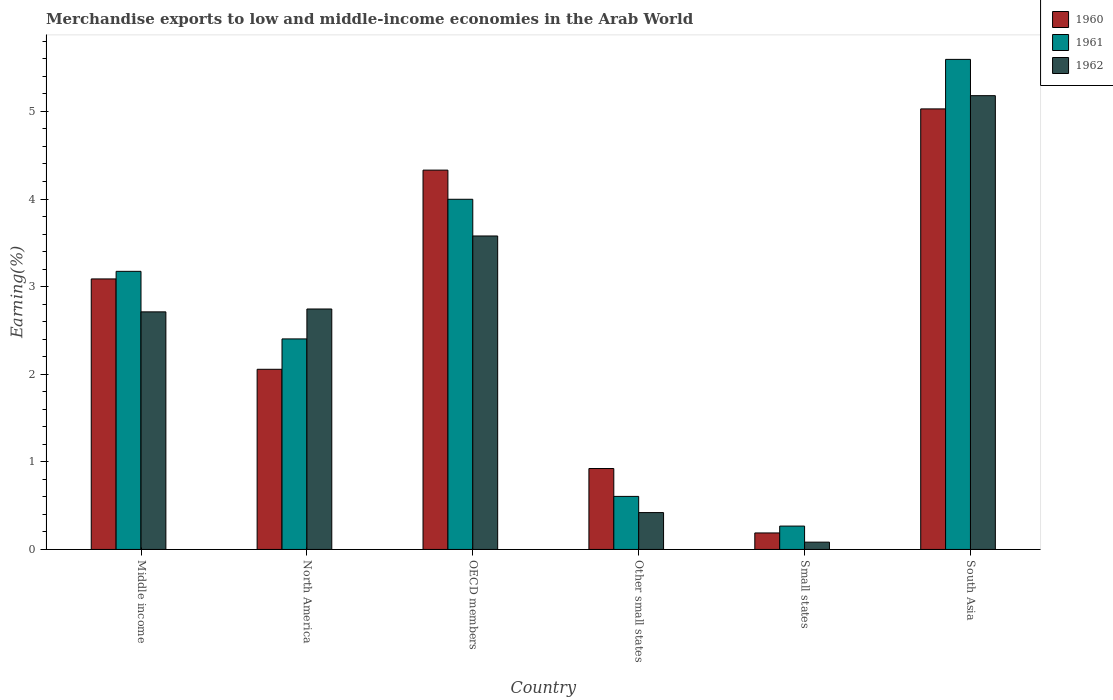How many different coloured bars are there?
Offer a terse response. 3. Are the number of bars per tick equal to the number of legend labels?
Offer a very short reply. Yes. Are the number of bars on each tick of the X-axis equal?
Give a very brief answer. Yes. What is the label of the 5th group of bars from the left?
Your answer should be very brief. Small states. In how many cases, is the number of bars for a given country not equal to the number of legend labels?
Your answer should be very brief. 0. What is the percentage of amount earned from merchandise exports in 1962 in Middle income?
Your answer should be compact. 2.71. Across all countries, what is the maximum percentage of amount earned from merchandise exports in 1962?
Your response must be concise. 5.18. Across all countries, what is the minimum percentage of amount earned from merchandise exports in 1961?
Ensure brevity in your answer.  0.27. In which country was the percentage of amount earned from merchandise exports in 1962 minimum?
Give a very brief answer. Small states. What is the total percentage of amount earned from merchandise exports in 1962 in the graph?
Your response must be concise. 14.72. What is the difference between the percentage of amount earned from merchandise exports in 1962 in North America and that in Small states?
Your response must be concise. 2.66. What is the difference between the percentage of amount earned from merchandise exports in 1962 in OECD members and the percentage of amount earned from merchandise exports in 1960 in South Asia?
Ensure brevity in your answer.  -1.45. What is the average percentage of amount earned from merchandise exports in 1961 per country?
Offer a terse response. 2.67. What is the difference between the percentage of amount earned from merchandise exports of/in 1962 and percentage of amount earned from merchandise exports of/in 1961 in South Asia?
Provide a short and direct response. -0.41. What is the ratio of the percentage of amount earned from merchandise exports in 1962 in Other small states to that in Small states?
Give a very brief answer. 5.05. Is the difference between the percentage of amount earned from merchandise exports in 1962 in Middle income and Small states greater than the difference between the percentage of amount earned from merchandise exports in 1961 in Middle income and Small states?
Make the answer very short. No. What is the difference between the highest and the second highest percentage of amount earned from merchandise exports in 1962?
Offer a terse response. -0.83. What is the difference between the highest and the lowest percentage of amount earned from merchandise exports in 1962?
Make the answer very short. 5.1. In how many countries, is the percentage of amount earned from merchandise exports in 1962 greater than the average percentage of amount earned from merchandise exports in 1962 taken over all countries?
Give a very brief answer. 4. Is the sum of the percentage of amount earned from merchandise exports in 1960 in Middle income and Small states greater than the maximum percentage of amount earned from merchandise exports in 1962 across all countries?
Provide a succinct answer. No. What does the 3rd bar from the left in Other small states represents?
Your response must be concise. 1962. What does the 1st bar from the right in South Asia represents?
Make the answer very short. 1962. How many bars are there?
Give a very brief answer. 18. Are all the bars in the graph horizontal?
Offer a terse response. No. How many countries are there in the graph?
Ensure brevity in your answer.  6. What is the difference between two consecutive major ticks on the Y-axis?
Your response must be concise. 1. Are the values on the major ticks of Y-axis written in scientific E-notation?
Keep it short and to the point. No. Does the graph contain any zero values?
Provide a short and direct response. No. Does the graph contain grids?
Ensure brevity in your answer.  No. Where does the legend appear in the graph?
Your answer should be compact. Top right. How many legend labels are there?
Give a very brief answer. 3. What is the title of the graph?
Give a very brief answer. Merchandise exports to low and middle-income economies in the Arab World. What is the label or title of the X-axis?
Your answer should be compact. Country. What is the label or title of the Y-axis?
Give a very brief answer. Earning(%). What is the Earning(%) in 1960 in Middle income?
Provide a short and direct response. 3.09. What is the Earning(%) of 1961 in Middle income?
Provide a succinct answer. 3.17. What is the Earning(%) of 1962 in Middle income?
Give a very brief answer. 2.71. What is the Earning(%) of 1960 in North America?
Provide a short and direct response. 2.06. What is the Earning(%) in 1961 in North America?
Your response must be concise. 2.4. What is the Earning(%) of 1962 in North America?
Give a very brief answer. 2.74. What is the Earning(%) of 1960 in OECD members?
Offer a very short reply. 4.33. What is the Earning(%) in 1961 in OECD members?
Provide a succinct answer. 4. What is the Earning(%) of 1962 in OECD members?
Provide a succinct answer. 3.58. What is the Earning(%) of 1960 in Other small states?
Your answer should be compact. 0.92. What is the Earning(%) in 1961 in Other small states?
Give a very brief answer. 0.61. What is the Earning(%) in 1962 in Other small states?
Keep it short and to the point. 0.42. What is the Earning(%) in 1960 in Small states?
Your response must be concise. 0.19. What is the Earning(%) in 1961 in Small states?
Your answer should be very brief. 0.27. What is the Earning(%) in 1962 in Small states?
Keep it short and to the point. 0.08. What is the Earning(%) in 1960 in South Asia?
Offer a very short reply. 5.03. What is the Earning(%) of 1961 in South Asia?
Your answer should be very brief. 5.59. What is the Earning(%) of 1962 in South Asia?
Make the answer very short. 5.18. Across all countries, what is the maximum Earning(%) of 1960?
Your answer should be very brief. 5.03. Across all countries, what is the maximum Earning(%) in 1961?
Provide a short and direct response. 5.59. Across all countries, what is the maximum Earning(%) of 1962?
Offer a terse response. 5.18. Across all countries, what is the minimum Earning(%) of 1960?
Give a very brief answer. 0.19. Across all countries, what is the minimum Earning(%) of 1961?
Give a very brief answer. 0.27. Across all countries, what is the minimum Earning(%) in 1962?
Offer a terse response. 0.08. What is the total Earning(%) of 1960 in the graph?
Give a very brief answer. 15.62. What is the total Earning(%) of 1961 in the graph?
Offer a very short reply. 16.04. What is the total Earning(%) of 1962 in the graph?
Make the answer very short. 14.72. What is the difference between the Earning(%) of 1960 in Middle income and that in North America?
Provide a short and direct response. 1.03. What is the difference between the Earning(%) of 1961 in Middle income and that in North America?
Provide a short and direct response. 0.77. What is the difference between the Earning(%) in 1962 in Middle income and that in North America?
Offer a very short reply. -0.03. What is the difference between the Earning(%) of 1960 in Middle income and that in OECD members?
Your response must be concise. -1.24. What is the difference between the Earning(%) of 1961 in Middle income and that in OECD members?
Make the answer very short. -0.82. What is the difference between the Earning(%) in 1962 in Middle income and that in OECD members?
Make the answer very short. -0.87. What is the difference between the Earning(%) of 1960 in Middle income and that in Other small states?
Offer a terse response. 2.16. What is the difference between the Earning(%) in 1961 in Middle income and that in Other small states?
Your answer should be compact. 2.57. What is the difference between the Earning(%) in 1962 in Middle income and that in Other small states?
Ensure brevity in your answer.  2.29. What is the difference between the Earning(%) in 1960 in Middle income and that in Small states?
Provide a succinct answer. 2.9. What is the difference between the Earning(%) of 1961 in Middle income and that in Small states?
Offer a very short reply. 2.91. What is the difference between the Earning(%) of 1962 in Middle income and that in Small states?
Provide a succinct answer. 2.63. What is the difference between the Earning(%) of 1960 in Middle income and that in South Asia?
Ensure brevity in your answer.  -1.94. What is the difference between the Earning(%) in 1961 in Middle income and that in South Asia?
Make the answer very short. -2.42. What is the difference between the Earning(%) of 1962 in Middle income and that in South Asia?
Keep it short and to the point. -2.47. What is the difference between the Earning(%) in 1960 in North America and that in OECD members?
Give a very brief answer. -2.27. What is the difference between the Earning(%) of 1961 in North America and that in OECD members?
Provide a succinct answer. -1.59. What is the difference between the Earning(%) in 1962 in North America and that in OECD members?
Ensure brevity in your answer.  -0.83. What is the difference between the Earning(%) of 1960 in North America and that in Other small states?
Make the answer very short. 1.13. What is the difference between the Earning(%) in 1961 in North America and that in Other small states?
Provide a short and direct response. 1.8. What is the difference between the Earning(%) in 1962 in North America and that in Other small states?
Ensure brevity in your answer.  2.32. What is the difference between the Earning(%) of 1960 in North America and that in Small states?
Give a very brief answer. 1.87. What is the difference between the Earning(%) in 1961 in North America and that in Small states?
Give a very brief answer. 2.14. What is the difference between the Earning(%) of 1962 in North America and that in Small states?
Offer a very short reply. 2.66. What is the difference between the Earning(%) of 1960 in North America and that in South Asia?
Provide a succinct answer. -2.97. What is the difference between the Earning(%) in 1961 in North America and that in South Asia?
Give a very brief answer. -3.19. What is the difference between the Earning(%) in 1962 in North America and that in South Asia?
Your response must be concise. -2.44. What is the difference between the Earning(%) of 1960 in OECD members and that in Other small states?
Provide a succinct answer. 3.41. What is the difference between the Earning(%) of 1961 in OECD members and that in Other small states?
Make the answer very short. 3.39. What is the difference between the Earning(%) in 1962 in OECD members and that in Other small states?
Your answer should be very brief. 3.16. What is the difference between the Earning(%) in 1960 in OECD members and that in Small states?
Make the answer very short. 4.14. What is the difference between the Earning(%) of 1961 in OECD members and that in Small states?
Your response must be concise. 3.73. What is the difference between the Earning(%) of 1962 in OECD members and that in Small states?
Your response must be concise. 3.49. What is the difference between the Earning(%) of 1960 in OECD members and that in South Asia?
Your answer should be very brief. -0.7. What is the difference between the Earning(%) of 1961 in OECD members and that in South Asia?
Provide a short and direct response. -1.6. What is the difference between the Earning(%) in 1962 in OECD members and that in South Asia?
Give a very brief answer. -1.6. What is the difference between the Earning(%) in 1960 in Other small states and that in Small states?
Offer a terse response. 0.74. What is the difference between the Earning(%) of 1961 in Other small states and that in Small states?
Your response must be concise. 0.34. What is the difference between the Earning(%) in 1962 in Other small states and that in Small states?
Offer a terse response. 0.34. What is the difference between the Earning(%) in 1960 in Other small states and that in South Asia?
Your answer should be compact. -4.1. What is the difference between the Earning(%) in 1961 in Other small states and that in South Asia?
Keep it short and to the point. -4.99. What is the difference between the Earning(%) of 1962 in Other small states and that in South Asia?
Keep it short and to the point. -4.76. What is the difference between the Earning(%) of 1960 in Small states and that in South Asia?
Make the answer very short. -4.84. What is the difference between the Earning(%) of 1961 in Small states and that in South Asia?
Provide a succinct answer. -5.33. What is the difference between the Earning(%) in 1962 in Small states and that in South Asia?
Keep it short and to the point. -5.1. What is the difference between the Earning(%) of 1960 in Middle income and the Earning(%) of 1961 in North America?
Your response must be concise. 0.68. What is the difference between the Earning(%) of 1960 in Middle income and the Earning(%) of 1962 in North America?
Offer a terse response. 0.34. What is the difference between the Earning(%) of 1961 in Middle income and the Earning(%) of 1962 in North America?
Provide a succinct answer. 0.43. What is the difference between the Earning(%) in 1960 in Middle income and the Earning(%) in 1961 in OECD members?
Provide a short and direct response. -0.91. What is the difference between the Earning(%) of 1960 in Middle income and the Earning(%) of 1962 in OECD members?
Provide a succinct answer. -0.49. What is the difference between the Earning(%) of 1961 in Middle income and the Earning(%) of 1962 in OECD members?
Keep it short and to the point. -0.4. What is the difference between the Earning(%) of 1960 in Middle income and the Earning(%) of 1961 in Other small states?
Keep it short and to the point. 2.48. What is the difference between the Earning(%) of 1960 in Middle income and the Earning(%) of 1962 in Other small states?
Offer a terse response. 2.67. What is the difference between the Earning(%) in 1961 in Middle income and the Earning(%) in 1962 in Other small states?
Offer a very short reply. 2.75. What is the difference between the Earning(%) in 1960 in Middle income and the Earning(%) in 1961 in Small states?
Your answer should be compact. 2.82. What is the difference between the Earning(%) in 1960 in Middle income and the Earning(%) in 1962 in Small states?
Provide a short and direct response. 3. What is the difference between the Earning(%) of 1961 in Middle income and the Earning(%) of 1962 in Small states?
Your response must be concise. 3.09. What is the difference between the Earning(%) of 1960 in Middle income and the Earning(%) of 1961 in South Asia?
Offer a terse response. -2.51. What is the difference between the Earning(%) in 1960 in Middle income and the Earning(%) in 1962 in South Asia?
Ensure brevity in your answer.  -2.09. What is the difference between the Earning(%) of 1961 in Middle income and the Earning(%) of 1962 in South Asia?
Offer a terse response. -2.01. What is the difference between the Earning(%) of 1960 in North America and the Earning(%) of 1961 in OECD members?
Provide a succinct answer. -1.94. What is the difference between the Earning(%) in 1960 in North America and the Earning(%) in 1962 in OECD members?
Provide a succinct answer. -1.52. What is the difference between the Earning(%) in 1961 in North America and the Earning(%) in 1962 in OECD members?
Your response must be concise. -1.17. What is the difference between the Earning(%) of 1960 in North America and the Earning(%) of 1961 in Other small states?
Your answer should be very brief. 1.45. What is the difference between the Earning(%) in 1960 in North America and the Earning(%) in 1962 in Other small states?
Give a very brief answer. 1.64. What is the difference between the Earning(%) in 1961 in North America and the Earning(%) in 1962 in Other small states?
Provide a succinct answer. 1.98. What is the difference between the Earning(%) of 1960 in North America and the Earning(%) of 1961 in Small states?
Make the answer very short. 1.79. What is the difference between the Earning(%) in 1960 in North America and the Earning(%) in 1962 in Small states?
Provide a succinct answer. 1.97. What is the difference between the Earning(%) in 1961 in North America and the Earning(%) in 1962 in Small states?
Provide a succinct answer. 2.32. What is the difference between the Earning(%) in 1960 in North America and the Earning(%) in 1961 in South Asia?
Your response must be concise. -3.54. What is the difference between the Earning(%) in 1960 in North America and the Earning(%) in 1962 in South Asia?
Provide a succinct answer. -3.12. What is the difference between the Earning(%) of 1961 in North America and the Earning(%) of 1962 in South Asia?
Provide a short and direct response. -2.78. What is the difference between the Earning(%) of 1960 in OECD members and the Earning(%) of 1961 in Other small states?
Your response must be concise. 3.72. What is the difference between the Earning(%) in 1960 in OECD members and the Earning(%) in 1962 in Other small states?
Make the answer very short. 3.91. What is the difference between the Earning(%) of 1961 in OECD members and the Earning(%) of 1962 in Other small states?
Keep it short and to the point. 3.58. What is the difference between the Earning(%) of 1960 in OECD members and the Earning(%) of 1961 in Small states?
Your response must be concise. 4.06. What is the difference between the Earning(%) in 1960 in OECD members and the Earning(%) in 1962 in Small states?
Provide a succinct answer. 4.25. What is the difference between the Earning(%) in 1961 in OECD members and the Earning(%) in 1962 in Small states?
Give a very brief answer. 3.91. What is the difference between the Earning(%) of 1960 in OECD members and the Earning(%) of 1961 in South Asia?
Offer a very short reply. -1.26. What is the difference between the Earning(%) of 1960 in OECD members and the Earning(%) of 1962 in South Asia?
Your answer should be compact. -0.85. What is the difference between the Earning(%) in 1961 in OECD members and the Earning(%) in 1962 in South Asia?
Offer a terse response. -1.18. What is the difference between the Earning(%) of 1960 in Other small states and the Earning(%) of 1961 in Small states?
Keep it short and to the point. 0.66. What is the difference between the Earning(%) of 1960 in Other small states and the Earning(%) of 1962 in Small states?
Offer a terse response. 0.84. What is the difference between the Earning(%) of 1961 in Other small states and the Earning(%) of 1962 in Small states?
Keep it short and to the point. 0.52. What is the difference between the Earning(%) of 1960 in Other small states and the Earning(%) of 1961 in South Asia?
Your answer should be compact. -4.67. What is the difference between the Earning(%) of 1960 in Other small states and the Earning(%) of 1962 in South Asia?
Offer a very short reply. -4.26. What is the difference between the Earning(%) in 1961 in Other small states and the Earning(%) in 1962 in South Asia?
Give a very brief answer. -4.57. What is the difference between the Earning(%) in 1960 in Small states and the Earning(%) in 1961 in South Asia?
Your answer should be compact. -5.41. What is the difference between the Earning(%) of 1960 in Small states and the Earning(%) of 1962 in South Asia?
Ensure brevity in your answer.  -4.99. What is the difference between the Earning(%) of 1961 in Small states and the Earning(%) of 1962 in South Asia?
Your response must be concise. -4.91. What is the average Earning(%) in 1960 per country?
Provide a short and direct response. 2.6. What is the average Earning(%) of 1961 per country?
Offer a terse response. 2.67. What is the average Earning(%) of 1962 per country?
Ensure brevity in your answer.  2.45. What is the difference between the Earning(%) of 1960 and Earning(%) of 1961 in Middle income?
Make the answer very short. -0.09. What is the difference between the Earning(%) in 1960 and Earning(%) in 1962 in Middle income?
Offer a very short reply. 0.38. What is the difference between the Earning(%) in 1961 and Earning(%) in 1962 in Middle income?
Offer a terse response. 0.46. What is the difference between the Earning(%) of 1960 and Earning(%) of 1961 in North America?
Offer a terse response. -0.35. What is the difference between the Earning(%) of 1960 and Earning(%) of 1962 in North America?
Your answer should be compact. -0.69. What is the difference between the Earning(%) of 1961 and Earning(%) of 1962 in North America?
Offer a terse response. -0.34. What is the difference between the Earning(%) of 1960 and Earning(%) of 1961 in OECD members?
Offer a very short reply. 0.33. What is the difference between the Earning(%) in 1960 and Earning(%) in 1962 in OECD members?
Your answer should be very brief. 0.75. What is the difference between the Earning(%) in 1961 and Earning(%) in 1962 in OECD members?
Give a very brief answer. 0.42. What is the difference between the Earning(%) of 1960 and Earning(%) of 1961 in Other small states?
Give a very brief answer. 0.32. What is the difference between the Earning(%) in 1960 and Earning(%) in 1962 in Other small states?
Offer a very short reply. 0.5. What is the difference between the Earning(%) in 1961 and Earning(%) in 1962 in Other small states?
Your answer should be very brief. 0.18. What is the difference between the Earning(%) of 1960 and Earning(%) of 1961 in Small states?
Ensure brevity in your answer.  -0.08. What is the difference between the Earning(%) of 1960 and Earning(%) of 1962 in Small states?
Provide a succinct answer. 0.11. What is the difference between the Earning(%) of 1961 and Earning(%) of 1962 in Small states?
Provide a succinct answer. 0.18. What is the difference between the Earning(%) in 1960 and Earning(%) in 1961 in South Asia?
Give a very brief answer. -0.57. What is the difference between the Earning(%) in 1960 and Earning(%) in 1962 in South Asia?
Your answer should be very brief. -0.15. What is the difference between the Earning(%) of 1961 and Earning(%) of 1962 in South Asia?
Offer a terse response. 0.41. What is the ratio of the Earning(%) in 1960 in Middle income to that in North America?
Ensure brevity in your answer.  1.5. What is the ratio of the Earning(%) in 1961 in Middle income to that in North America?
Ensure brevity in your answer.  1.32. What is the ratio of the Earning(%) of 1960 in Middle income to that in OECD members?
Offer a terse response. 0.71. What is the ratio of the Earning(%) of 1961 in Middle income to that in OECD members?
Provide a succinct answer. 0.79. What is the ratio of the Earning(%) in 1962 in Middle income to that in OECD members?
Provide a short and direct response. 0.76. What is the ratio of the Earning(%) in 1960 in Middle income to that in Other small states?
Your answer should be very brief. 3.34. What is the ratio of the Earning(%) in 1961 in Middle income to that in Other small states?
Keep it short and to the point. 5.24. What is the ratio of the Earning(%) of 1962 in Middle income to that in Other small states?
Make the answer very short. 6.44. What is the ratio of the Earning(%) of 1960 in Middle income to that in Small states?
Your answer should be compact. 16.39. What is the ratio of the Earning(%) in 1961 in Middle income to that in Small states?
Make the answer very short. 11.9. What is the ratio of the Earning(%) in 1962 in Middle income to that in Small states?
Keep it short and to the point. 32.54. What is the ratio of the Earning(%) in 1960 in Middle income to that in South Asia?
Offer a very short reply. 0.61. What is the ratio of the Earning(%) in 1961 in Middle income to that in South Asia?
Your answer should be compact. 0.57. What is the ratio of the Earning(%) in 1962 in Middle income to that in South Asia?
Provide a short and direct response. 0.52. What is the ratio of the Earning(%) of 1960 in North America to that in OECD members?
Keep it short and to the point. 0.47. What is the ratio of the Earning(%) in 1961 in North America to that in OECD members?
Make the answer very short. 0.6. What is the ratio of the Earning(%) in 1962 in North America to that in OECD members?
Provide a short and direct response. 0.77. What is the ratio of the Earning(%) of 1960 in North America to that in Other small states?
Give a very brief answer. 2.23. What is the ratio of the Earning(%) in 1961 in North America to that in Other small states?
Keep it short and to the point. 3.97. What is the ratio of the Earning(%) of 1962 in North America to that in Other small states?
Offer a very short reply. 6.52. What is the ratio of the Earning(%) in 1960 in North America to that in Small states?
Provide a succinct answer. 10.91. What is the ratio of the Earning(%) of 1961 in North America to that in Small states?
Keep it short and to the point. 9.01. What is the ratio of the Earning(%) in 1962 in North America to that in Small states?
Your answer should be compact. 32.94. What is the ratio of the Earning(%) of 1960 in North America to that in South Asia?
Keep it short and to the point. 0.41. What is the ratio of the Earning(%) of 1961 in North America to that in South Asia?
Ensure brevity in your answer.  0.43. What is the ratio of the Earning(%) of 1962 in North America to that in South Asia?
Provide a short and direct response. 0.53. What is the ratio of the Earning(%) of 1960 in OECD members to that in Other small states?
Offer a terse response. 4.69. What is the ratio of the Earning(%) of 1961 in OECD members to that in Other small states?
Ensure brevity in your answer.  6.6. What is the ratio of the Earning(%) in 1962 in OECD members to that in Other small states?
Provide a succinct answer. 8.5. What is the ratio of the Earning(%) in 1960 in OECD members to that in Small states?
Offer a very short reply. 22.98. What is the ratio of the Earning(%) in 1961 in OECD members to that in Small states?
Ensure brevity in your answer.  14.98. What is the ratio of the Earning(%) of 1962 in OECD members to that in Small states?
Your answer should be very brief. 42.94. What is the ratio of the Earning(%) of 1960 in OECD members to that in South Asia?
Ensure brevity in your answer.  0.86. What is the ratio of the Earning(%) of 1961 in OECD members to that in South Asia?
Offer a very short reply. 0.71. What is the ratio of the Earning(%) of 1962 in OECD members to that in South Asia?
Offer a very short reply. 0.69. What is the ratio of the Earning(%) of 1960 in Other small states to that in Small states?
Provide a short and direct response. 4.9. What is the ratio of the Earning(%) of 1961 in Other small states to that in Small states?
Provide a succinct answer. 2.27. What is the ratio of the Earning(%) of 1962 in Other small states to that in Small states?
Provide a short and direct response. 5.05. What is the ratio of the Earning(%) in 1960 in Other small states to that in South Asia?
Ensure brevity in your answer.  0.18. What is the ratio of the Earning(%) of 1961 in Other small states to that in South Asia?
Give a very brief answer. 0.11. What is the ratio of the Earning(%) in 1962 in Other small states to that in South Asia?
Provide a short and direct response. 0.08. What is the ratio of the Earning(%) of 1960 in Small states to that in South Asia?
Your answer should be very brief. 0.04. What is the ratio of the Earning(%) in 1961 in Small states to that in South Asia?
Make the answer very short. 0.05. What is the ratio of the Earning(%) of 1962 in Small states to that in South Asia?
Your answer should be compact. 0.02. What is the difference between the highest and the second highest Earning(%) in 1960?
Provide a short and direct response. 0.7. What is the difference between the highest and the second highest Earning(%) of 1961?
Ensure brevity in your answer.  1.6. What is the difference between the highest and the second highest Earning(%) of 1962?
Make the answer very short. 1.6. What is the difference between the highest and the lowest Earning(%) of 1960?
Provide a short and direct response. 4.84. What is the difference between the highest and the lowest Earning(%) of 1961?
Make the answer very short. 5.33. What is the difference between the highest and the lowest Earning(%) in 1962?
Your answer should be very brief. 5.1. 